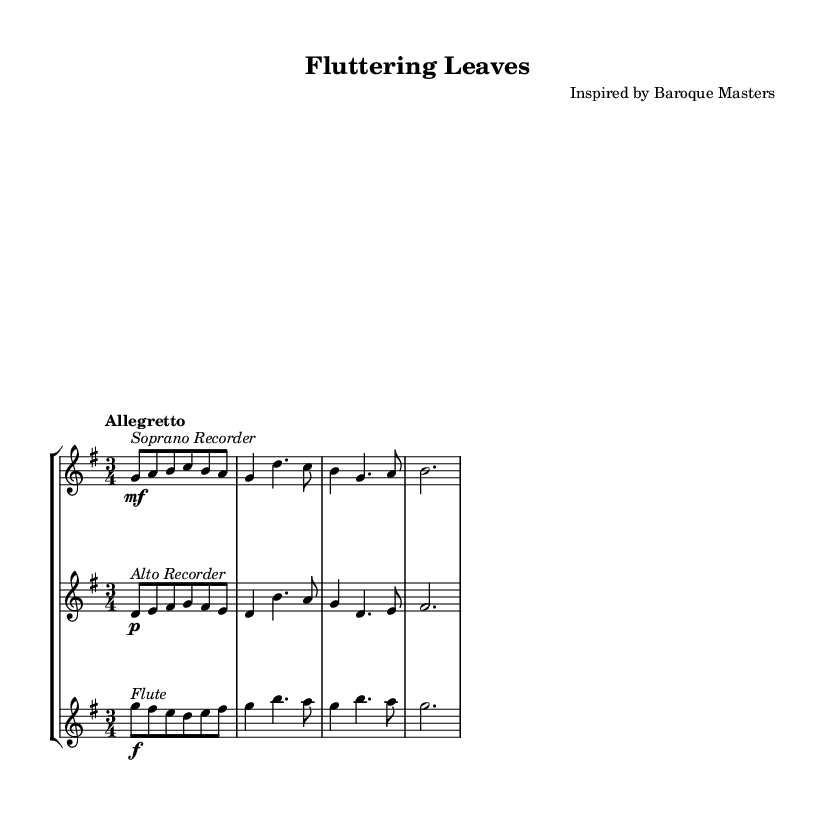What is the key signature of this music? The key signature is G major, which has one sharp (F#). You can identify this by looking at the key signature indicated at the beginning of the staff, where there is a single sharp.
Answer: G major What is the time signature of this music? The time signature is 3/4, which indicates that there are three beats in each measure and the quarter note gets one beat. You can find this written at the beginning of the sheet music next to the key signature.
Answer: 3/4 What is the tempo marking of this piece? The tempo marking is "Allegretto," which suggests a moderately fast tempo. This is typically found at the top of the score, indicating how quickly the music should be played.
Answer: Allegretto How many instruments are featured in this piece? There are three instruments featured: Soprano Recorder, Alto Recorder, and Flute. By examining the staff groups in the score, you can see each instrument is arranged on its own staff.
Answer: Three Which instrument plays the melody primarily? The Flute primarily plays the melody, as it is notated with the uppermost staff and has more prominent notes. In chamber music settings, the instrument on the highest staff often carries the main melody line.
Answer: Flute What dynamic marking is indicated for the Soprano Recorder? The dynamic marking for the Soprano Recorder is "mf," which stands for mezzo-forte, indicating a moderately loud dynamic. This instruction is shown next to the notes of the Soprano Recorder.
Answer: mf Which section of the ensemble plays softer in this piece? The Alto Recorder plays softer, as indicated by the "p" marking next to its notes, meaning piano or soft. Typically, dynamic markings are shown near the notes, and in this case, it clearly indicates a soft volume.
Answer: Alto Recorder 